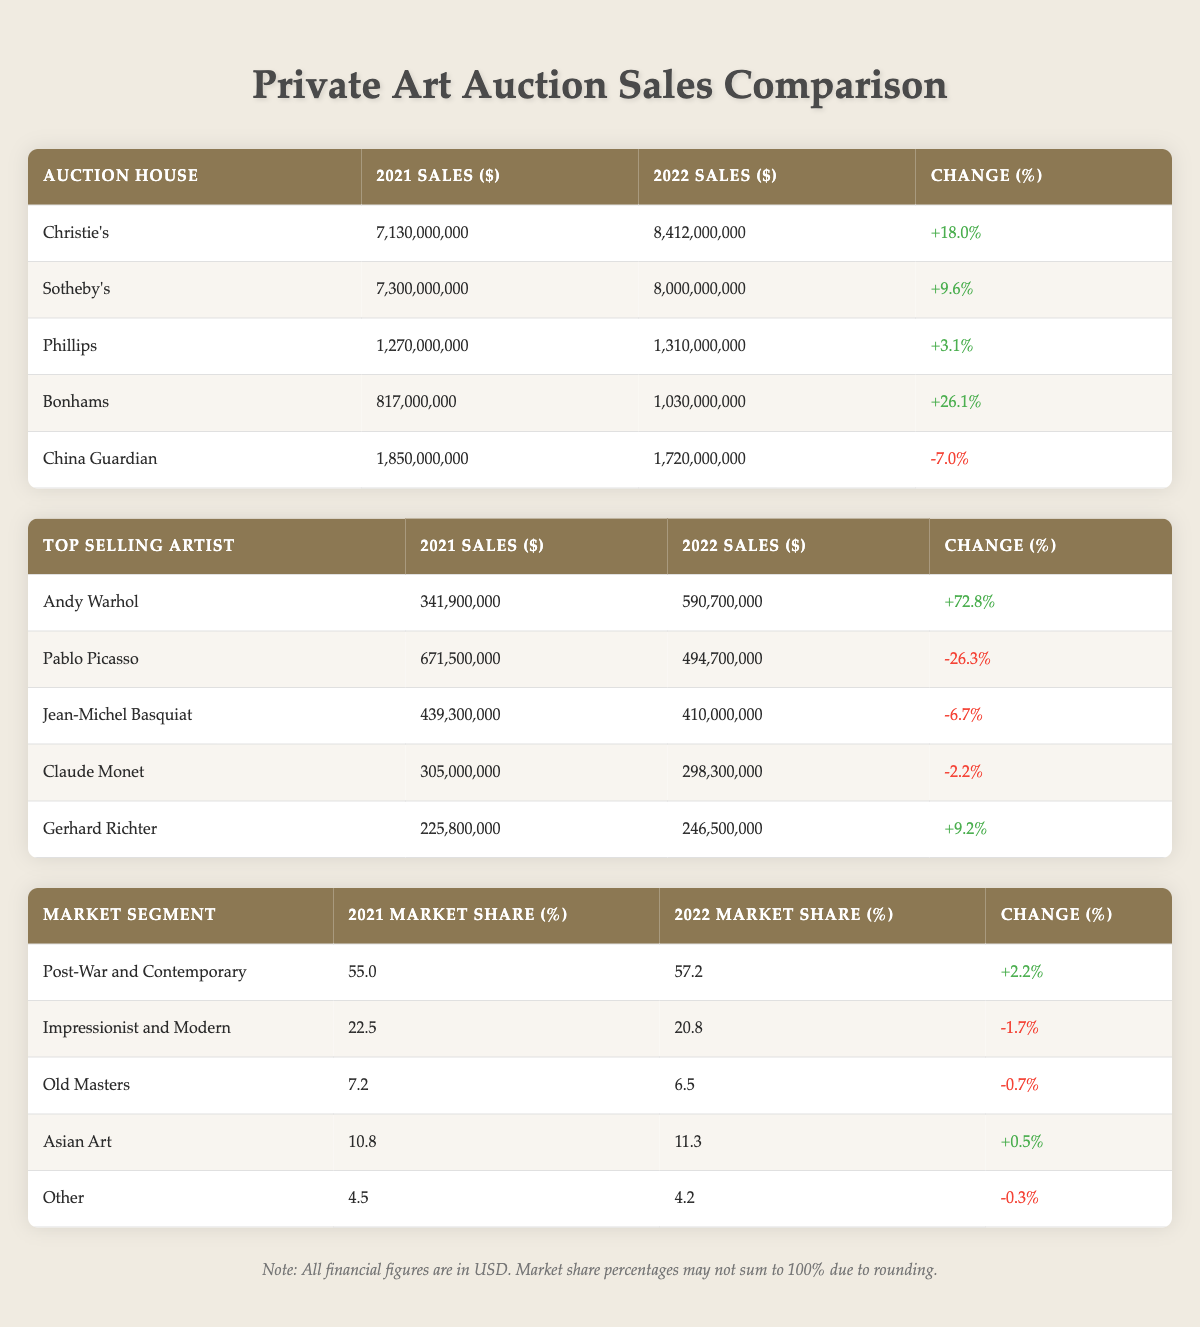What was the total sales for Christie's in 2022? In the table, Christie's sales for 2022 are listed as 8,412,000,000.
Answer: 8,412,000,000 Which auction house had the highest percentage increase in sales from 2021 to 2022? By comparing the percentage change across all auction houses, Bonhams had the highest increase of 26.1%.
Answer: Bonhams What is the average sales change for the top selling artists? To find the average sales change, we sum the percentage changes for all top artists (72.8 - 26.3 - 6.7 - 2.2 + 9.2) = 47.8, and then divide by the number of artists (5). 47.8/5 = 9.56.
Answer: 9.56 Did China Guardian have an increase or decrease in sales from 2021 to 2022? The table shows that China Guardian's sales decreased from 1,850,000,000 in 2021 to 1,720,000,000 in 2022, which indicates a decrease.
Answer: Decrease Which market segment experienced a decline in market share? Upon reviewing market segments, both Impressionist and Modern (-1.7%) and Old Masters (-0.7%) experienced a decline in market share.
Answer: Impressionist and Modern, Old Masters What was the combined market share of the Post-War and Contemporary and Asian Art segments in 2022? In 2022, Post-War and Contemporary had a market share of 57.2% and Asian Art had 11.3%. Adding these together gives 57.2 + 11.3 = 68.5%.
Answer: 68.5% Which artist had the greatest decrease in sales from 2021 to 2022? Comparing the changes in sales, Pablo Picasso had the greatest decrease, with a change of -26.3%.
Answer: Pablo Picasso What is the total sales for Phillips in 2021 and 2022 combined? By summing Phillips sales from both years, we get 1,270,000,000 (2021) + 1,310,000,000 (2022) = 2,580,000,000.
Answer: 2,580,000,000 Is the total sales for Sotheby's greater than Christie's sales in 2021? Sotheby’s sales in 2021 were 7,300,000,000 and Christie's were 7,130,000,000, thus Sotheby's is greater.
Answer: Yes 